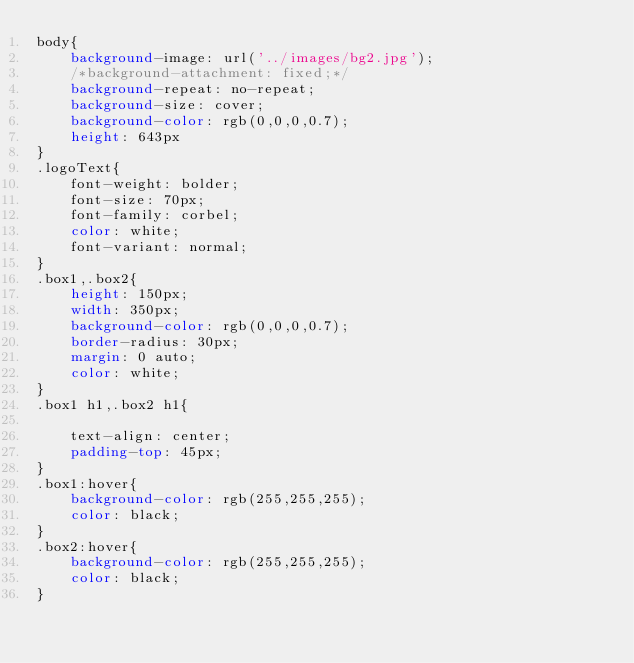<code> <loc_0><loc_0><loc_500><loc_500><_CSS_>body{
	background-image: url('../images/bg2.jpg');
	/*background-attachment: fixed;*/
	background-repeat: no-repeat;
	background-size: cover;
	background-color: rgb(0,0,0,0.7);
	height: 643px
}
.logoText{
	font-weight: bolder;
	font-size: 70px;
	font-family: corbel;
	color: white;
	font-variant: normal;
}
.box1,.box2{
	height: 150px;
	width: 350px;
	background-color: rgb(0,0,0,0.7);
	border-radius: 30px;
	margin: 0 auto;
	color: white;
}
.box1 h1,.box2 h1{
	
	text-align: center;
	padding-top: 45px;
}
.box1:hover{
	background-color: rgb(255,255,255);
	color: black;
}
.box2:hover{
	background-color: rgb(255,255,255);
	color: black;
}</code> 